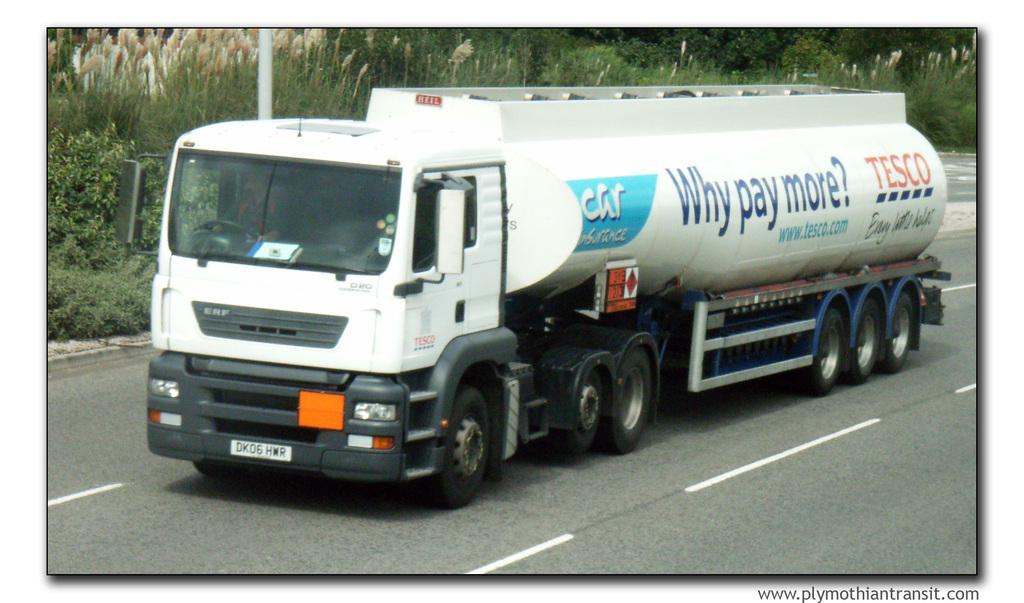How would you summarize this image in a sentence or two? There is a truck on the road. On the truck there is something written. In the back there are plants, trees, and a pole. And a person is sitting in the truck. 